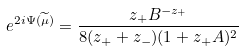Convert formula to latex. <formula><loc_0><loc_0><loc_500><loc_500>e ^ { 2 i \Psi ( \widetilde { \mu } ) } = \frac { z _ { + } B ^ { - z _ { + } } } { 8 ( z _ { + } + z _ { - } ) ( 1 + z _ { + } A ) ^ { 2 } }</formula> 